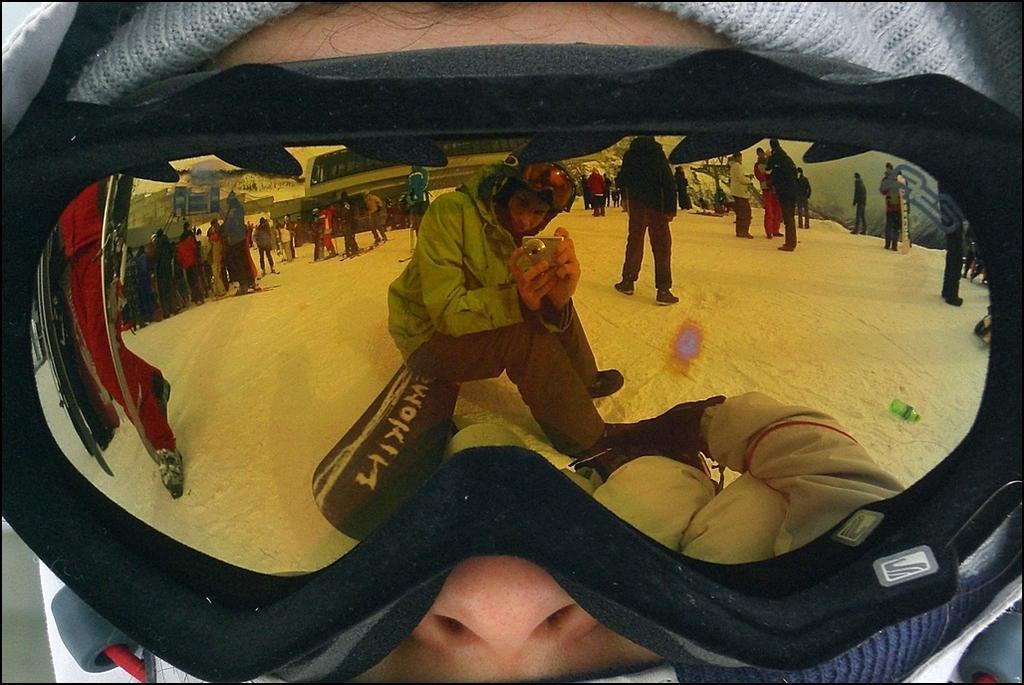Can you describe this image briefly? In this picture we can see a person wearing a goggles, here we can see a person sitting on a snow board, wearing a helmet and holding a camera and in the background we can see a group of people, buildings, snow and some objects. 